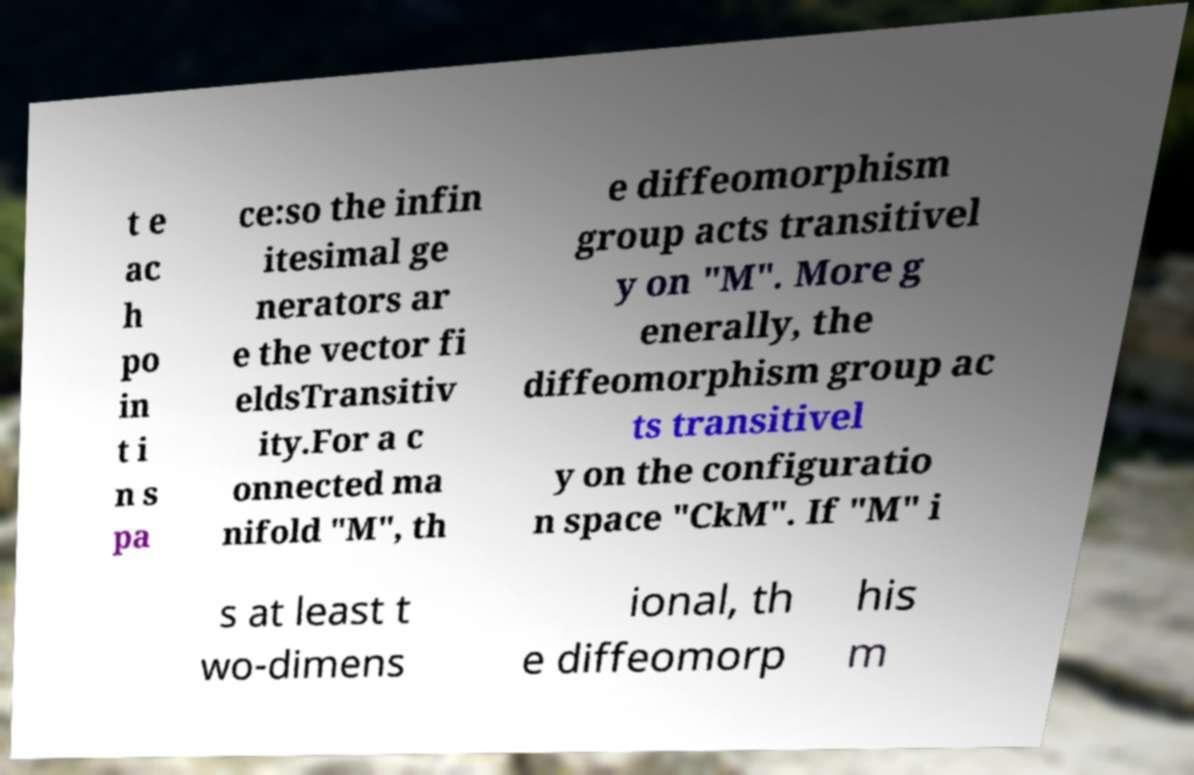Can you read and provide the text displayed in the image?This photo seems to have some interesting text. Can you extract and type it out for me? t e ac h po in t i n s pa ce:so the infin itesimal ge nerators ar e the vector fi eldsTransitiv ity.For a c onnected ma nifold "M", th e diffeomorphism group acts transitivel y on "M". More g enerally, the diffeomorphism group ac ts transitivel y on the configuratio n space "CkM". If "M" i s at least t wo-dimens ional, th e diffeomorp his m 